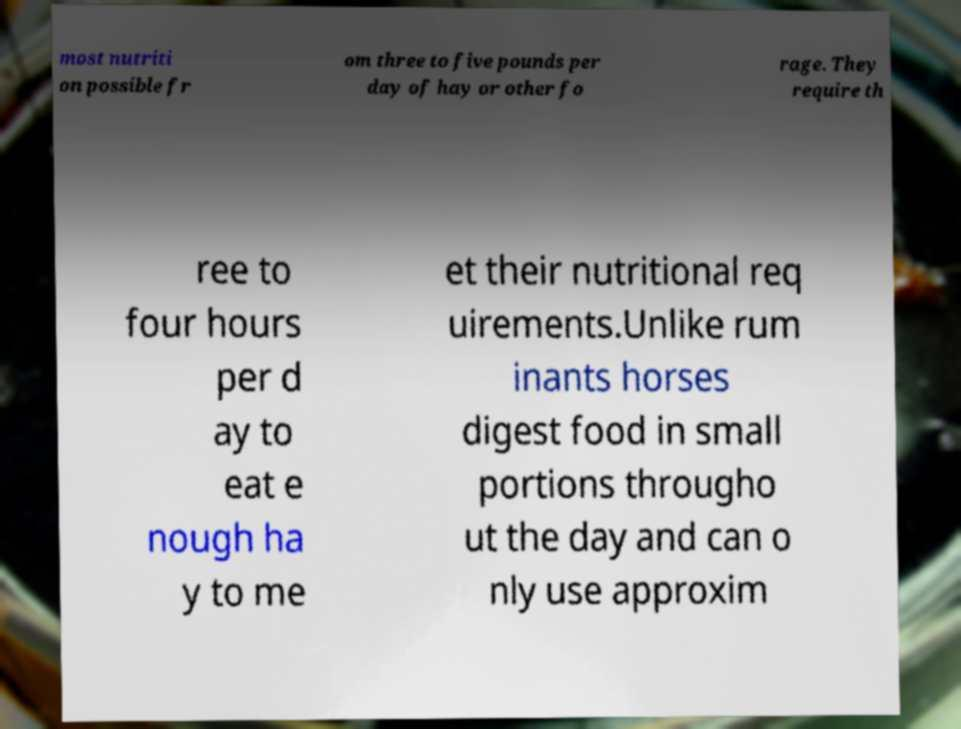Can you read and provide the text displayed in the image?This photo seems to have some interesting text. Can you extract and type it out for me? most nutriti on possible fr om three to five pounds per day of hay or other fo rage. They require th ree to four hours per d ay to eat e nough ha y to me et their nutritional req uirements.Unlike rum inants horses digest food in small portions througho ut the day and can o nly use approxim 